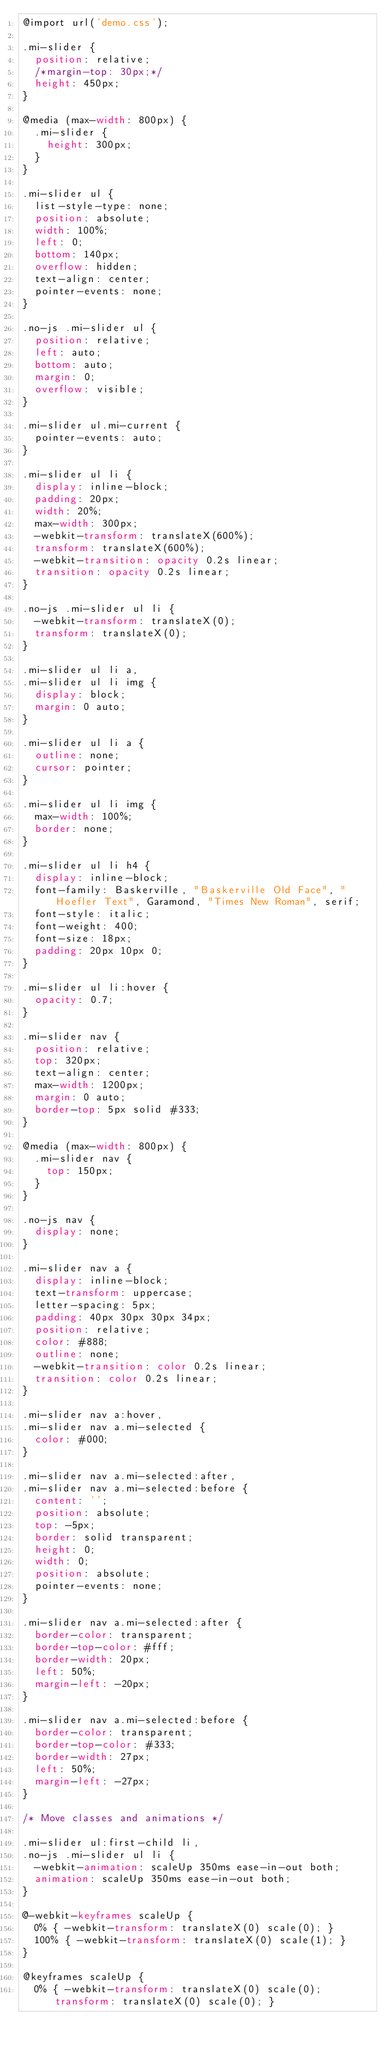Convert code to text. <code><loc_0><loc_0><loc_500><loc_500><_CSS_>@import url('demo.css');

.mi-slider {
	position: relative;
	/*margin-top: 30px;*/
	height: 450px;
}

@media (max-width: 800px) {
	.mi-slider {
		height: 300px;
	}
}

.mi-slider ul {
	list-style-type: none;
	position: absolute;
	width: 100%;
	left: 0;
	bottom: 140px;
	overflow: hidden;
	text-align: center;
	pointer-events: none;
}

.no-js .mi-slider ul {
	position: relative;
	left: auto;
	bottom: auto;
	margin: 0;
	overflow: visible;
}

.mi-slider ul.mi-current {
	pointer-events: auto;
}

.mi-slider ul li {
	display: inline-block;
	padding: 20px;
	width: 20%;
	max-width: 300px;
	-webkit-transform: translateX(600%);
	transform: translateX(600%);
	-webkit-transition: opacity 0.2s linear;
	transition: opacity 0.2s linear;
}

.no-js .mi-slider ul li {
	-webkit-transform: translateX(0);
	transform: translateX(0);
}

.mi-slider ul li a,
.mi-slider ul li img {
	display: block;
	margin: 0 auto;
}

.mi-slider ul li a {
	outline: none;
	cursor: pointer;
}

.mi-slider ul li img {
	max-width: 100%;
	border: none;
}

.mi-slider ul li h4 {
	display: inline-block;
	font-family: Baskerville, "Baskerville Old Face", "Hoefler Text", Garamond, "Times New Roman", serif;
	font-style: italic;
	font-weight: 400;
	font-size: 18px;
	padding: 20px 10px 0;
}

.mi-slider ul li:hover {
	opacity: 0.7;
} 

.mi-slider nav {
	position: relative;
	top: 320px;
	text-align: center;
	max-width: 1200px;
	margin: 0 auto;
	border-top: 5px solid #333;
}

@media (max-width: 800px) {
	.mi-slider nav {
		top: 150px;
	}
}

.no-js nav {
	display: none;
}

.mi-slider nav a {
	display: inline-block;
	text-transform: uppercase;
	letter-spacing: 5px;
	padding: 40px 30px 30px 34px;
	position: relative;
	color: #888;
	outline: none;
	-webkit-transition: color 0.2s linear;
	transition: color 0.2s linear;
}

.mi-slider nav a:hover,
.mi-slider nav a.mi-selected {
	color: #000;
}

.mi-slider nav a.mi-selected:after,
.mi-slider nav a.mi-selected:before {
	content: '';
	position: absolute;
	top: -5px;
	border: solid transparent;
	height: 0;
	width: 0;
	position: absolute;
	pointer-events: none;
}

.mi-slider nav a.mi-selected:after {
	border-color: transparent;
	border-top-color: #fff;
	border-width: 20px;
	left: 50%;
	margin-left: -20px;
}

.mi-slider nav a.mi-selected:before {
	border-color: transparent;
	border-top-color: #333;
	border-width: 27px;
	left: 50%;
	margin-left: -27px;
}

/* Move classes and animations */

.mi-slider ul:first-child li,
.no-js .mi-slider ul li {
	-webkit-animation: scaleUp 350ms ease-in-out both;
	animation: scaleUp 350ms ease-in-out both;
}

@-webkit-keyframes scaleUp {
	0% { -webkit-transform: translateX(0) scale(0); }
	100% { -webkit-transform: translateX(0) scale(1); }
}

@keyframes scaleUp {
	0% { -webkit-transform: translateX(0) scale(0); transform: translateX(0) scale(0); }</code> 